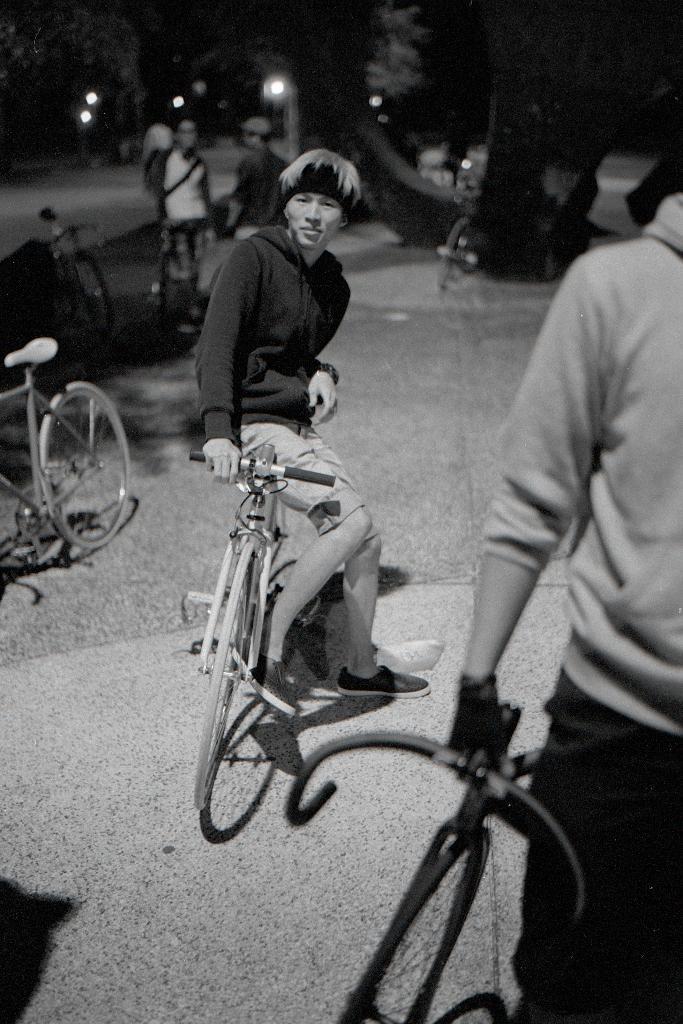Can you describe this image briefly? This black and white picture is taken on road. In the center of the image there is a man sitting on a bicycle. To the right corner of the image there is another person holding a bicycle in his hand. To the left of the image there are few bicycles parked. In the background there are trees, street lights and few people. 